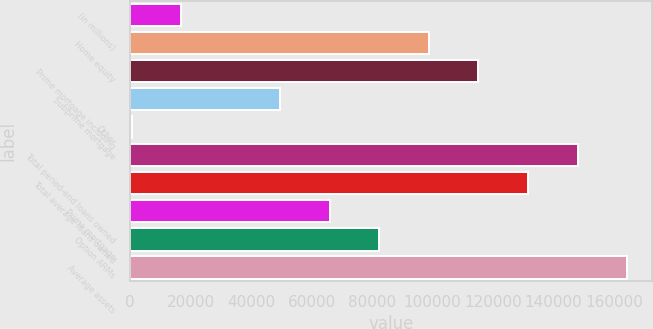Convert chart. <chart><loc_0><loc_0><loc_500><loc_500><bar_chart><fcel>(in millions)<fcel>Home equity<fcel>Prime mortgage including<fcel>Subprime mortgage<fcel>Other<fcel>Total period-end loans owned<fcel>Total average loans owned<fcel>Prime mortgage<fcel>Option ARMs<fcel>Average assets<nl><fcel>16868<fcel>98823<fcel>115214<fcel>49650<fcel>477<fcel>147996<fcel>131605<fcel>66041<fcel>82432<fcel>164387<nl></chart> 